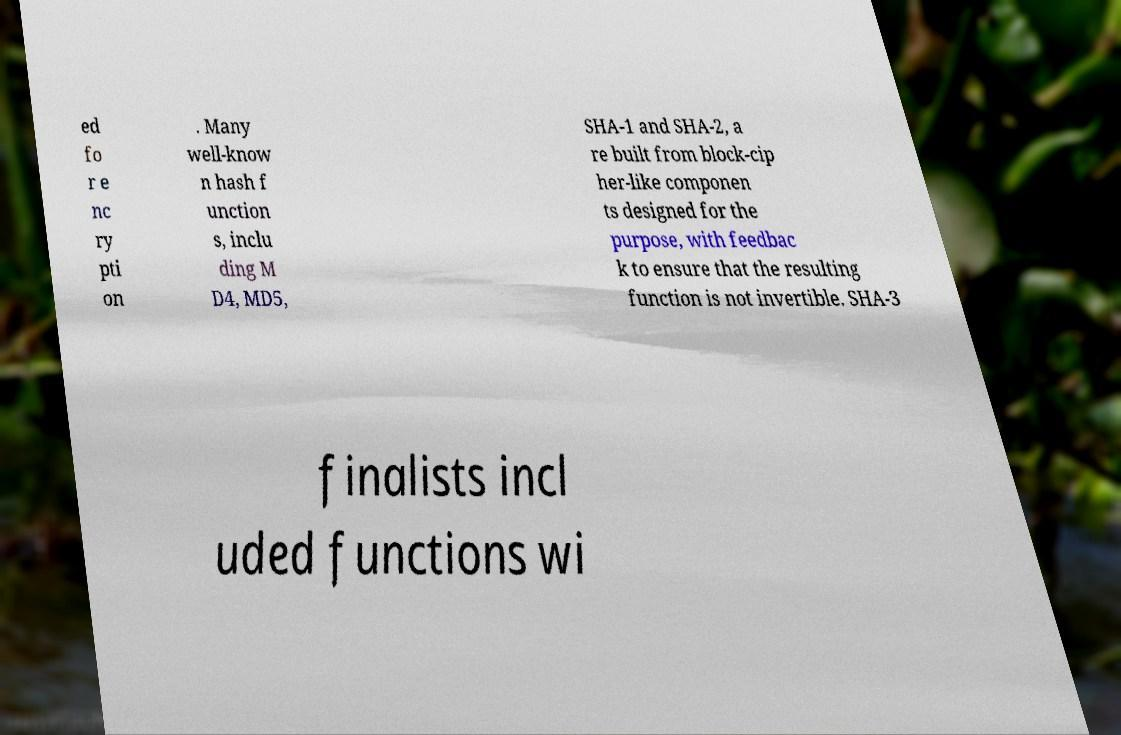There's text embedded in this image that I need extracted. Can you transcribe it verbatim? ed fo r e nc ry pti on . Many well-know n hash f unction s, inclu ding M D4, MD5, SHA-1 and SHA-2, a re built from block-cip her-like componen ts designed for the purpose, with feedbac k to ensure that the resulting function is not invertible. SHA-3 finalists incl uded functions wi 